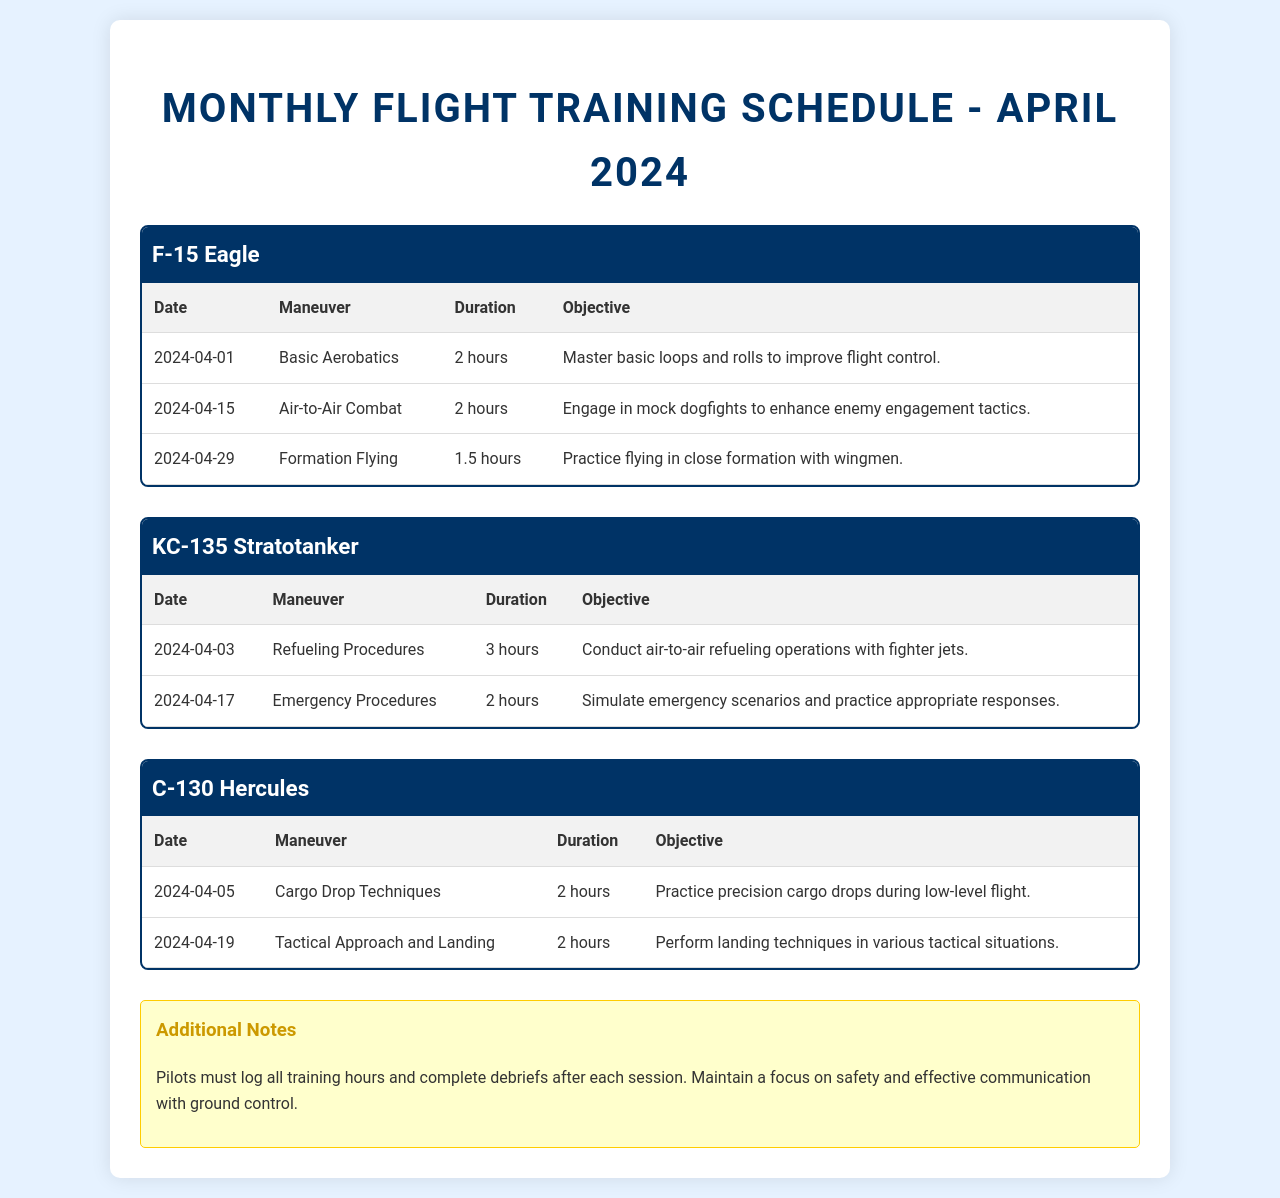What is the date for the Basic Aerobatics maneuver in the F-15 Eagle? The document lists the date for the Basic Aerobatics maneuver as April 1, 2024.
Answer: April 1, 2024 How long is the training session for Refueling Procedures in the KC-135 Stratotanker? According to the schedule, the Refueling Procedures session lasts for 3 hours.
Answer: 3 hours What is the objective of the Tactical Approach and Landing maneuver in the C-130 Hercules? The document states that the objective is to perform landing techniques in various tactical situations.
Answer: Perform landing techniques in various tactical situations How many training sessions are scheduled for the KC-135 Stratotanker in April 2024? The schedule shows that there are two training sessions planned for the KC-135 Stratotanker.
Answer: Two What kind of maneuvers will be practiced on April 15 for the F-15 Eagle? The F-15 Eagle will focus on Air-to-Air Combat on April 15.
Answer: Air-to-Air Combat Which aircraft has a training session planned for April 29, 2024? The document indicates that the F-15 Eagle has a session for Formation Flying scheduled for April 29, 2024.
Answer: F-15 Eagle What additional note is mentioned for pilots after each training session? The document notes that pilots must log all training hours and complete debriefs after each session.
Answer: Log all training hours and complete debriefs after each session What is the duration of the Air-to-Air Combat session in the F-15 Eagle? The scheduled duration for the Air-to-Air Combat session is 2 hours.
Answer: 2 hours 